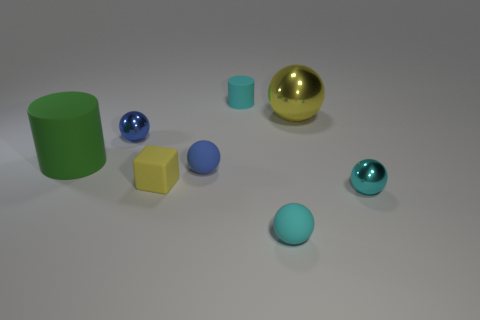What size is the other object that is the same shape as the large green thing?
Provide a short and direct response. Small. How many things are large green cylinders or yellow metal things?
Provide a short and direct response. 2. Is the number of large yellow metallic objects behind the small matte cylinder the same as the number of gray metal blocks?
Your response must be concise. Yes. There is a small cyan object behind the shiny ball that is in front of the big cylinder; is there a cyan rubber ball in front of it?
Ensure brevity in your answer.  Yes. There is a tiny cylinder that is the same material as the cube; what color is it?
Ensure brevity in your answer.  Cyan. Is the color of the rubber ball to the right of the tiny cyan cylinder the same as the matte block?
Your response must be concise. No. How many cubes are either big yellow objects or large blue rubber things?
Ensure brevity in your answer.  0. There is a blue thing that is in front of the cylinder that is in front of the tiny blue thing left of the blue matte thing; how big is it?
Your response must be concise. Small. There is a green object that is the same size as the yellow metallic thing; what is its shape?
Provide a short and direct response. Cylinder. What is the shape of the tiny yellow rubber thing?
Give a very brief answer. Cube. 